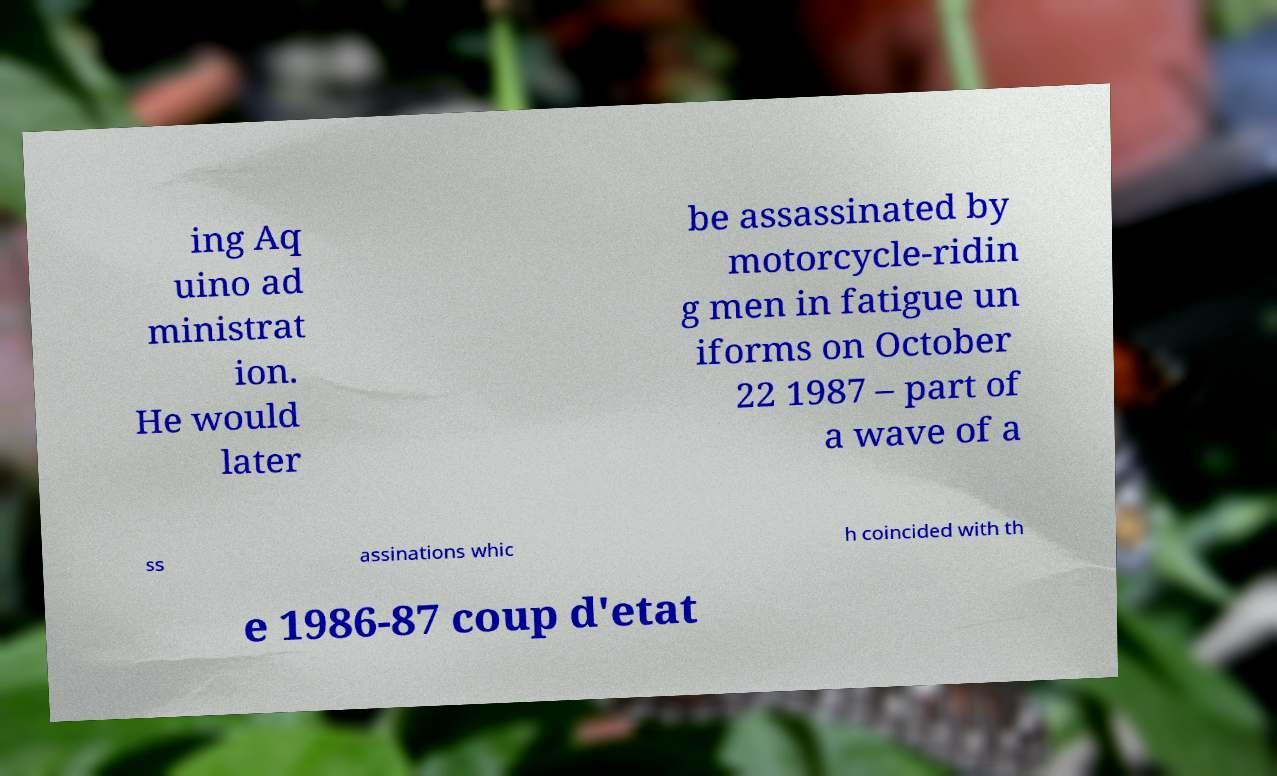Could you assist in decoding the text presented in this image and type it out clearly? ing Aq uino ad ministrat ion. He would later be assassinated by motorcycle-ridin g men in fatigue un iforms on October 22 1987 – part of a wave of a ss assinations whic h coincided with th e 1986-87 coup d'etat 